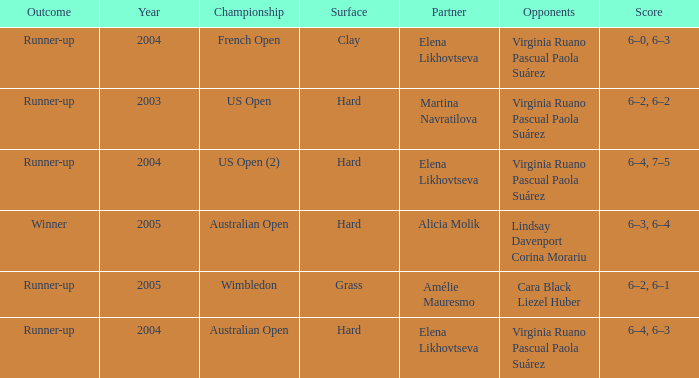When Australian open is the championship what is the lowest year? 2004.0. 